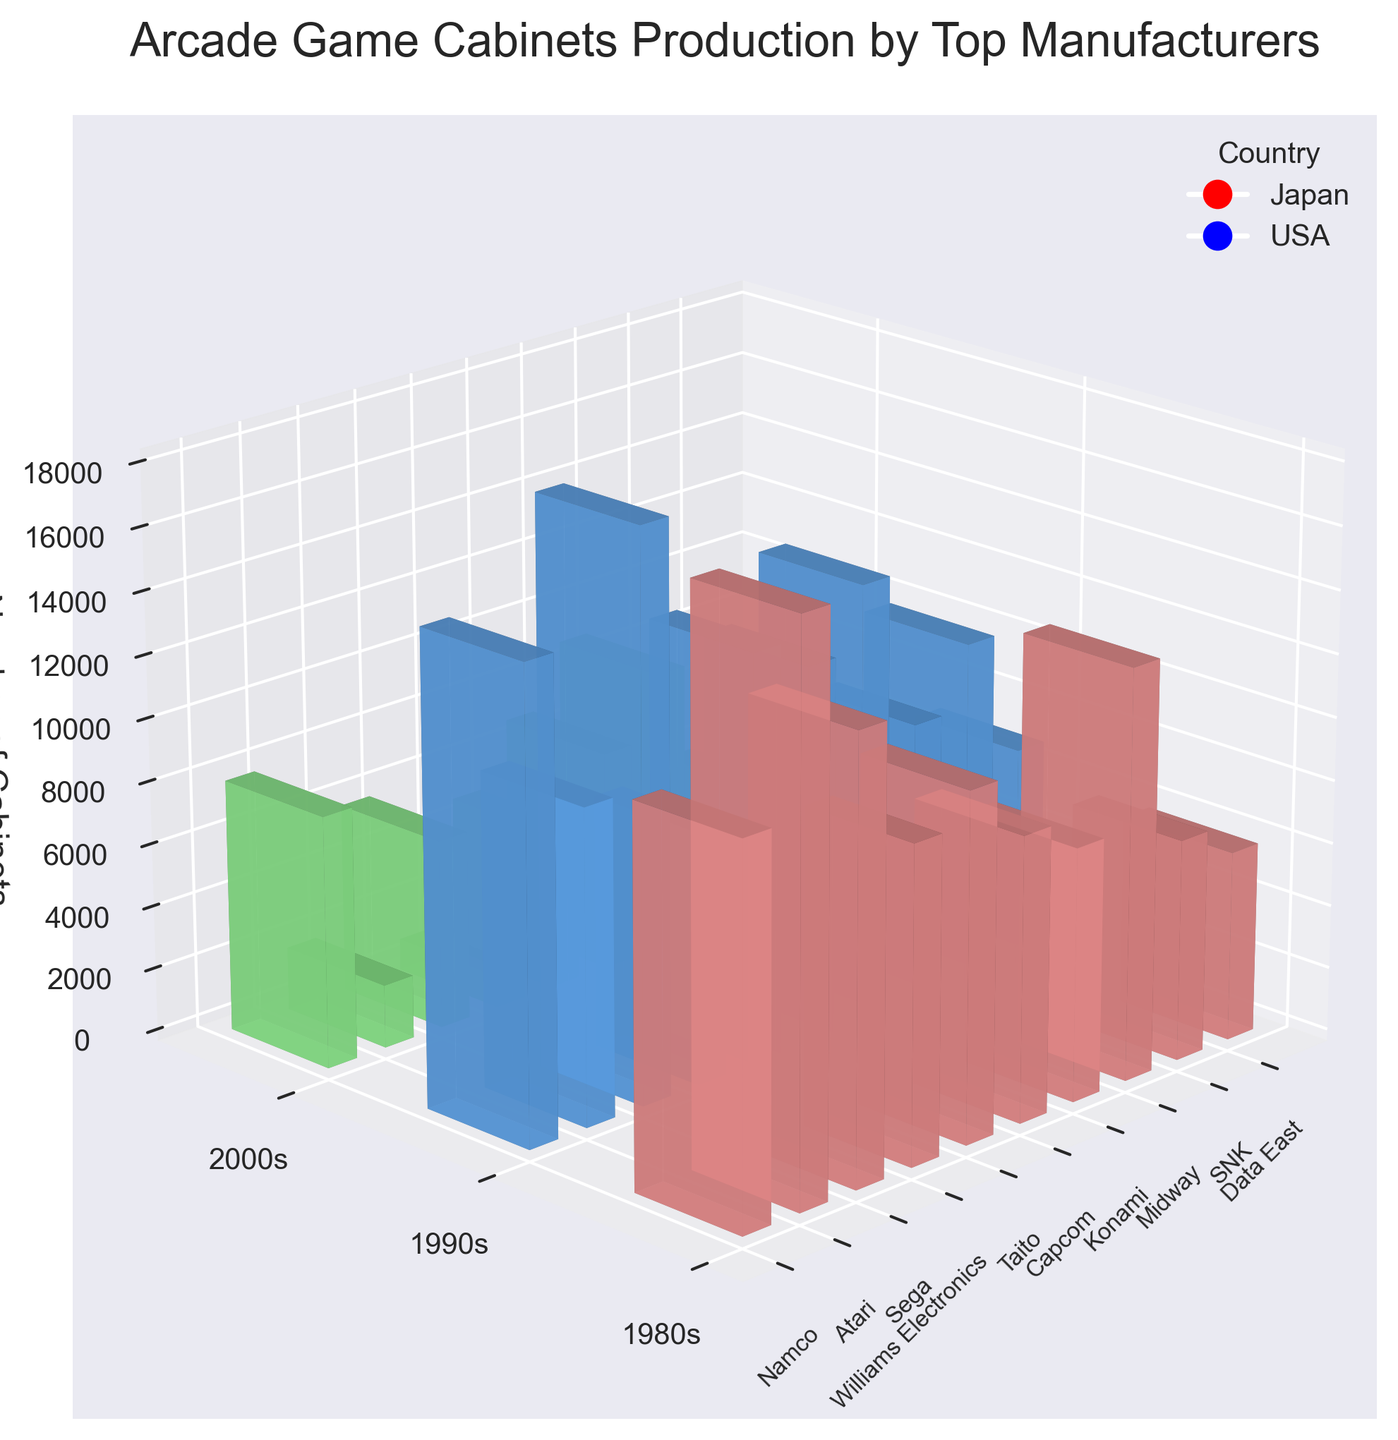what is the title of the plot? The title is located at the top of the figure. It provides a brief description of what the plot represents.
Answer: Arcade Game Cabinets Production by Top Manufacturers how many manufacturers are represented in the figure? Count the number of manufacturer names shown along the x-axis.
Answer: 10 which decade saw the highest production for Namco? Look at the bars corresponding to Namco and compare the heights for each decade (1980s, 1990s, 2000s).
Answer: 1990s what is the average number of cabinets produced by Atari in the 1980s and 1990s? Find the production numbers for Atari in the 1980s and 1990s, sum them up, and divide by 2: (18000 + 10000) / 2.
Answer: 14000 which manufacturer from Japan produced the most cabinets in the 2000s? Identify the manufacturers from Japan along the x-axis and compare the heights of their bars corresponding to the 2000s.
Answer: Konami how does the cabinet production of Williams Electronics in the 1980s compare to that of the 1990s? Compare the heights of the bars representing Williams Electronics for the 1980s and 1990s.
Answer: Higher in the 1980s in which decade did USA produce more cabinets compared to Japan? Sum the heights of the bars for manufacturers from the USA and Japan for each decade and compare.
Answer: 1980s what is the trend in the production of cabinets by Sega over the decades? Observe the heights of the bars representing Sega for each decade and describe the change over time.
Answer: Increased in the 1990s, then decreased which country has the most total manufacturers represented in the plot? Count the number of manufacturers from each country based on the legend and x-axis labels.
Answer: Japan how does the cabinet production compare between Midway and Taito in the 2000s? Compare the heights of the bars representing Midway and Taito for the 2000s.
Answer: Taito produced more 